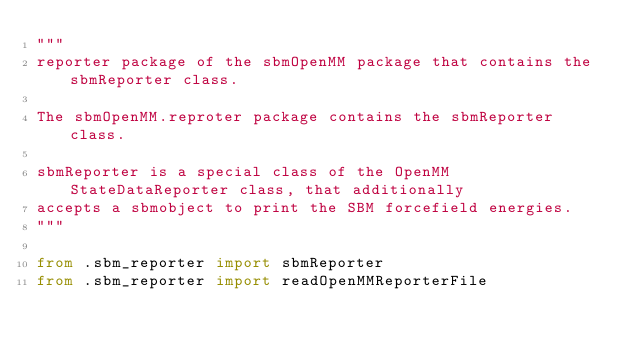<code> <loc_0><loc_0><loc_500><loc_500><_Python_>"""
reporter package of the sbmOpenMM package that contains the sbmReporter class.

The sbmOpenMM.reproter package contains the sbmReporter class.

sbmReporter is a special class of the OpenMM StateDataReporter class, that additionally
accepts a sbmobject to print the SBM forcefield energies.
"""

from .sbm_reporter import sbmReporter
from .sbm_reporter import readOpenMMReporterFile
</code> 